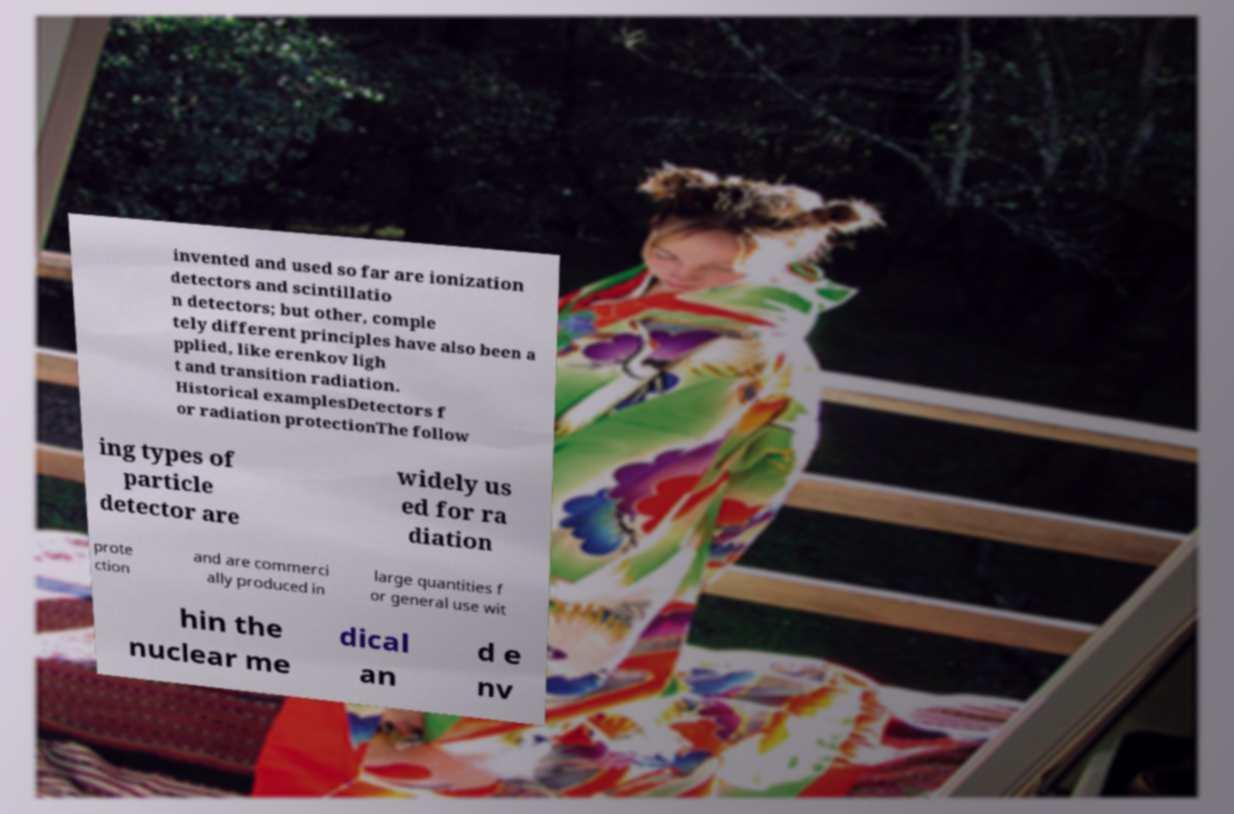Please identify and transcribe the text found in this image. invented and used so far are ionization detectors and scintillatio n detectors; but other, comple tely different principles have also been a pplied, like erenkov ligh t and transition radiation. Historical examplesDetectors f or radiation protectionThe follow ing types of particle detector are widely us ed for ra diation prote ction and are commerci ally produced in large quantities f or general use wit hin the nuclear me dical an d e nv 